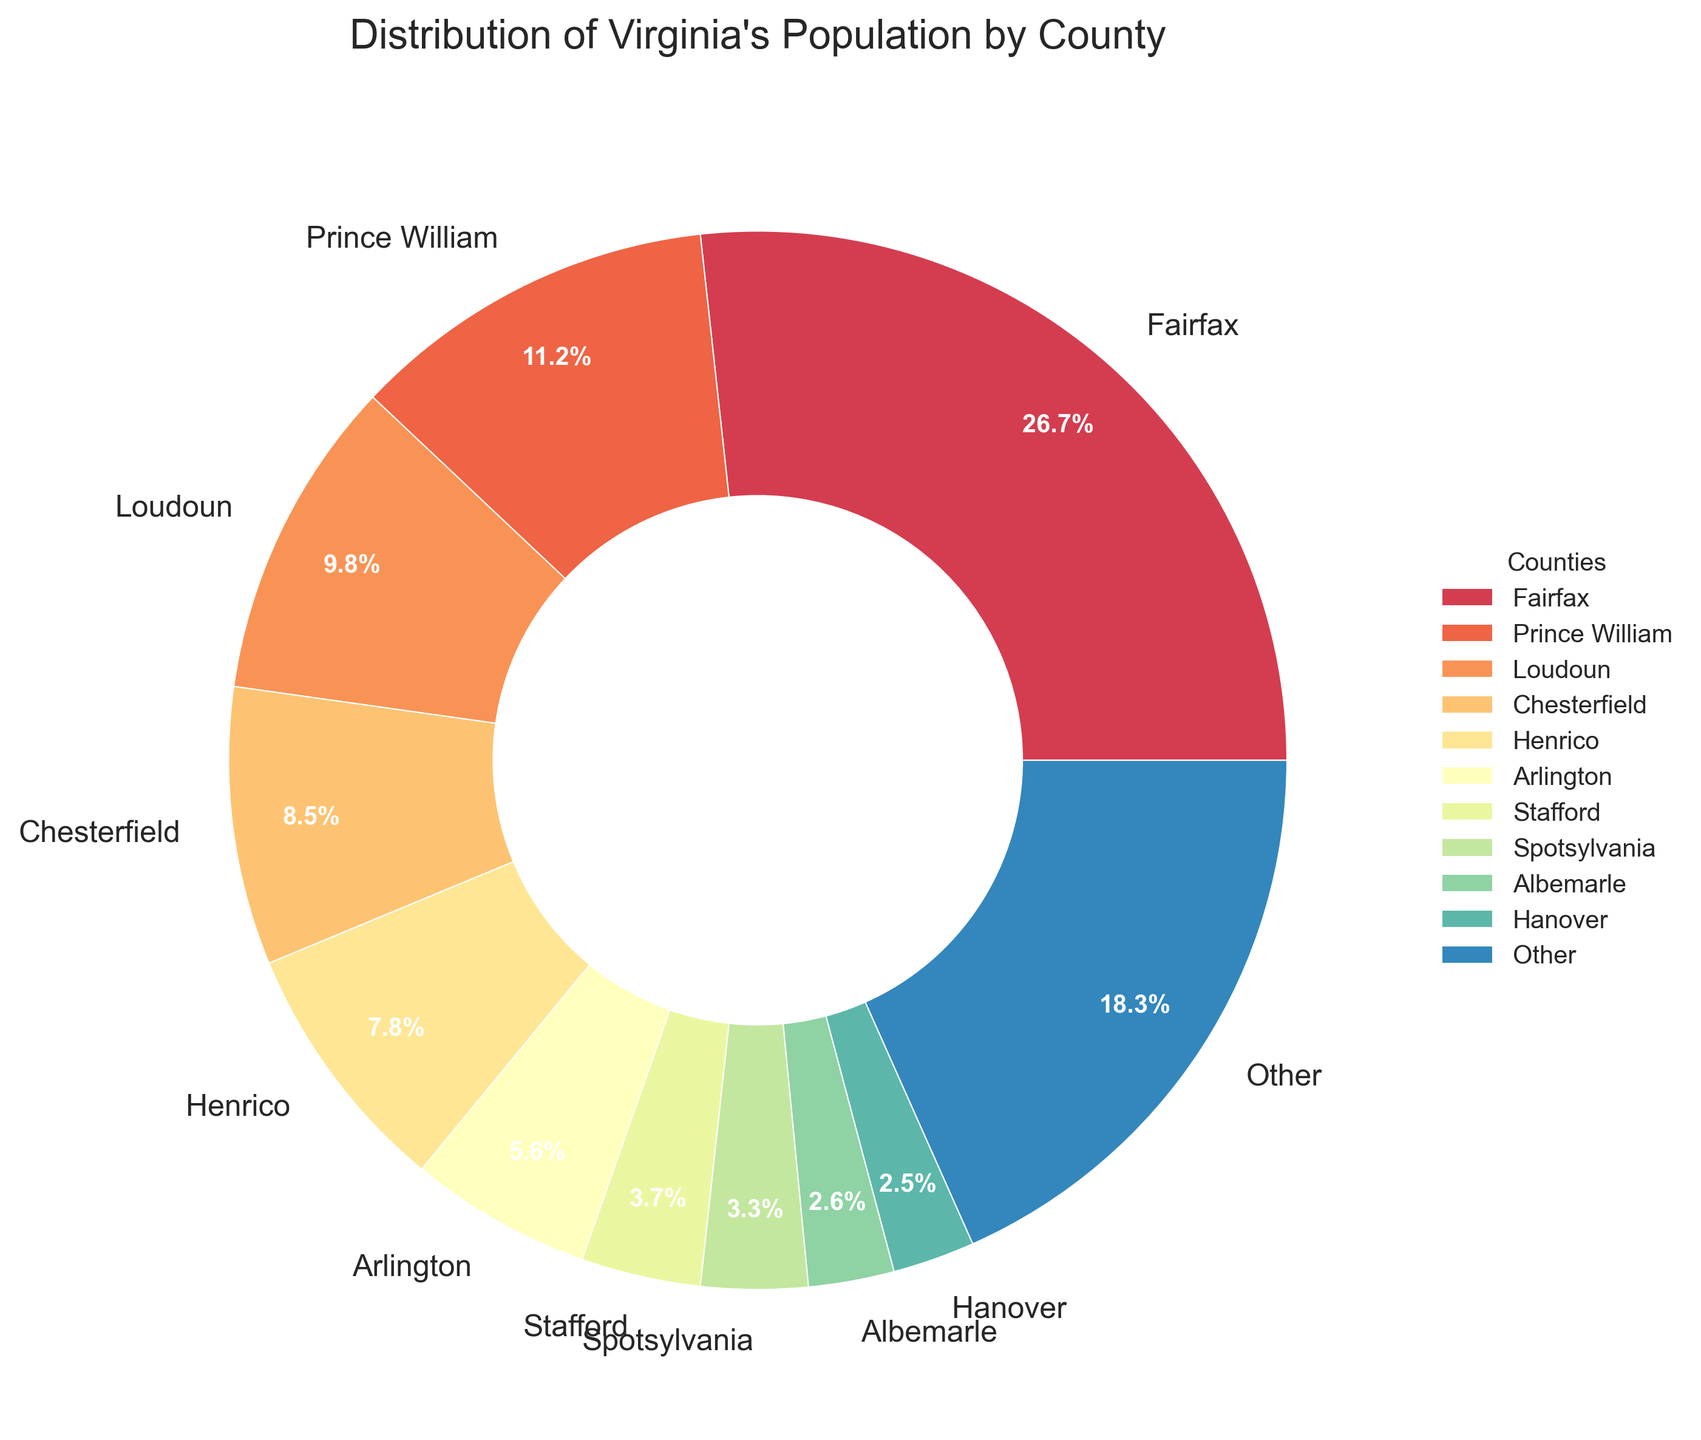What percentage of Virginia's population lives in Fairfax County? By looking at the pie chart, you can see the percentage label on Fairfax County’s segment.
Answer: 14.7% Which county has a higher population: Prince William or Loudoun? By comparing the size of the pie segments and their corresponding percentage labels, we see that Prince William County has 6.2%, whereas Loudoun County has 5.4%. Thus, Prince William has a higher population.
Answer: Prince William What is the combined percentage of population in Chesterfield, Henrico, and Arlington counties? By adding the percentages directly from the pie chart: Chesterfield (4.7%) + Henrico (4.3%) + Arlington (3.1%) = 12.1%.
Answer: 12.1% Which counties are in the top 3 by population percentage? The top 3 counties can be identified by the largest slices in the pie chart, which are Fairfax, Prince William, and Loudoun.
Answer: Fairfax, Prince William, Loudoun How does the population percentage of Stafford compare to that of Spotsylvania? The chart shows Stafford has 2.0%, while Spotsylvania has 1.8%. Stafford’s slice is slightly larger than Spotsylvania’s.
Answer: Stafford is higher What percentage of the population resides in counties other than the top 10? From the pie chart, the 'Other' category represents the population of all counties outside the top 10, which is given as 26.3%.
Answer: 26.3% What is the total percentage of population residing in Frederick, Augusta, and Bedford counties combined? By summing their percentages directly from the chart: Frederick (1.2%), Augusta (1.0%), Bedford (1.0%) = 3.2%.
Answer: 3.2% What is the difference in population percentage between Fairfax County and Roanoke? Fairfax has 14.7% and Roanoke has 1.3%. The difference is 14.7% - 1.3% = 13.4%.
Answer: 13.4% Which county has the smallest percentage labeled on the chart? The smallest percentage shown on the chart is for Roanoke County with 1.3%.
Answer: Roanoke Is Henrico County's population percentage larger or smaller than Albemarle County's? By comparing their segments on the pie chart, Henrico has 4.3% while Albemarle has 1.4%. Henrico’s percentage is larger.
Answer: Larger 